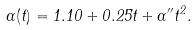Convert formula to latex. <formula><loc_0><loc_0><loc_500><loc_500>\alpha ( t ) = 1 . 1 0 + 0 . 2 5 t + \alpha ^ { \prime \prime } t ^ { 2 } .</formula> 